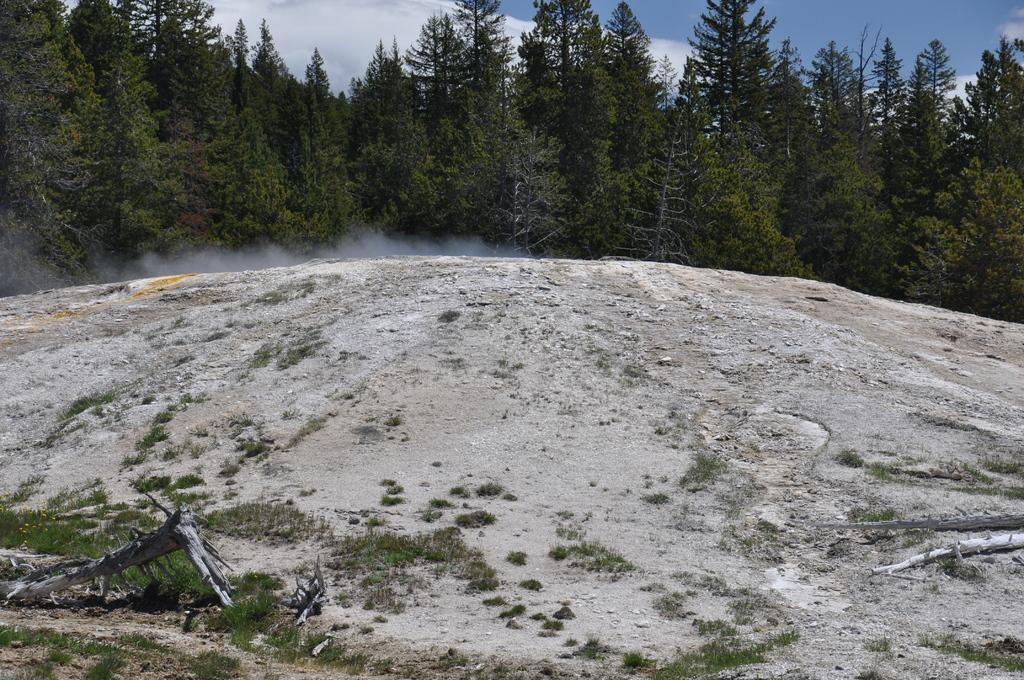Describe this image in one or two sentences. In the center of the image we can see the sky, clouds, trees, smoke, grass and one stem of a tree. 